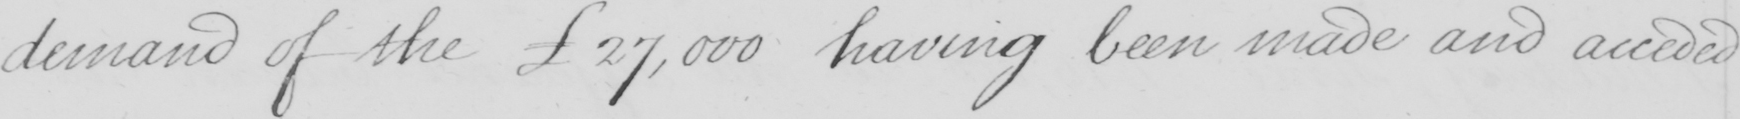What does this handwritten line say? demand of the   £27,000 having been made and acceded 